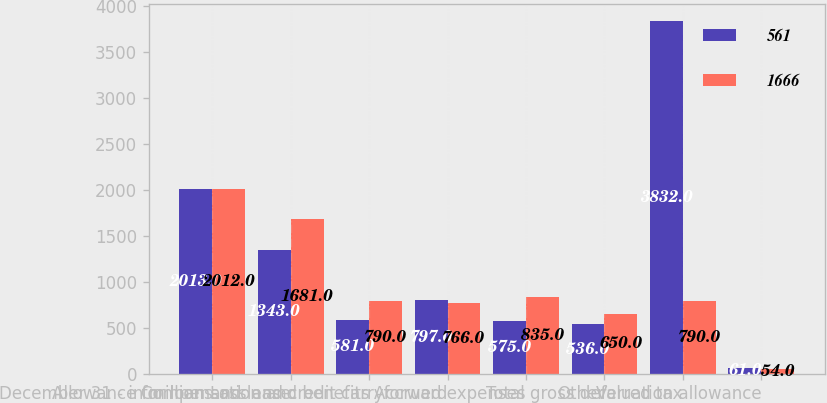<chart> <loc_0><loc_0><loc_500><loc_500><stacked_bar_chart><ecel><fcel>December 31 - in millions<fcel>Allowance for loan and lease<fcel>Compensation and benefits<fcel>Loss and credit carryforward<fcel>Accrued expenses<fcel>Other<fcel>Total gross deferred tax<fcel>Valuation allowance<nl><fcel>561<fcel>2013<fcel>1343<fcel>581<fcel>797<fcel>575<fcel>536<fcel>3832<fcel>61<nl><fcel>1666<fcel>2012<fcel>1681<fcel>790<fcel>766<fcel>835<fcel>650<fcel>790<fcel>54<nl></chart> 